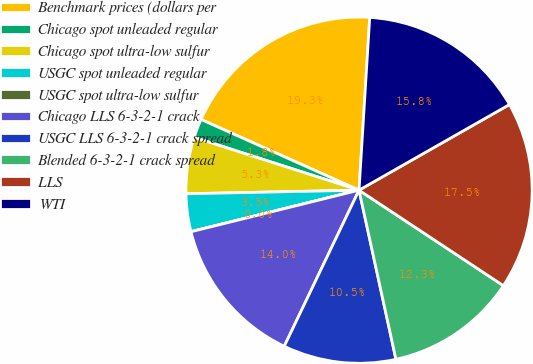<chart> <loc_0><loc_0><loc_500><loc_500><pie_chart><fcel>Benchmark prices (dollars per<fcel>Chicago spot unleaded regular<fcel>Chicago spot ultra-low sulfur<fcel>USGC spot unleaded regular<fcel>USGC spot ultra-low sulfur<fcel>Chicago LLS 6-3-2-1 crack<fcel>USGC LLS 6-3-2-1 crack spread<fcel>Blended 6-3-2-1 crack spread<fcel>LLS<fcel>WTI<nl><fcel>19.29%<fcel>1.76%<fcel>5.27%<fcel>3.52%<fcel>0.01%<fcel>14.03%<fcel>10.53%<fcel>12.28%<fcel>17.54%<fcel>15.78%<nl></chart> 